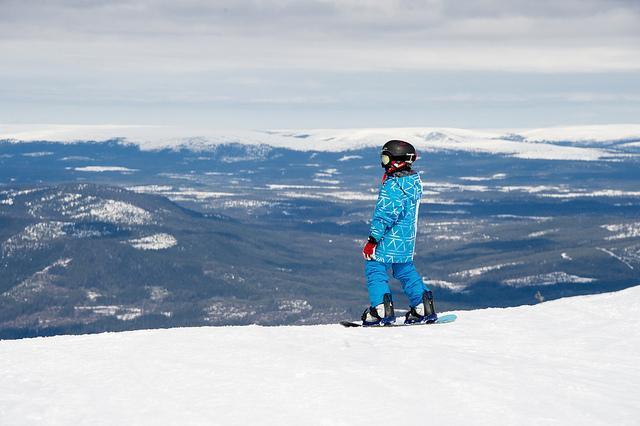How many people are using backpacks or bags?
Give a very brief answer. 0. 